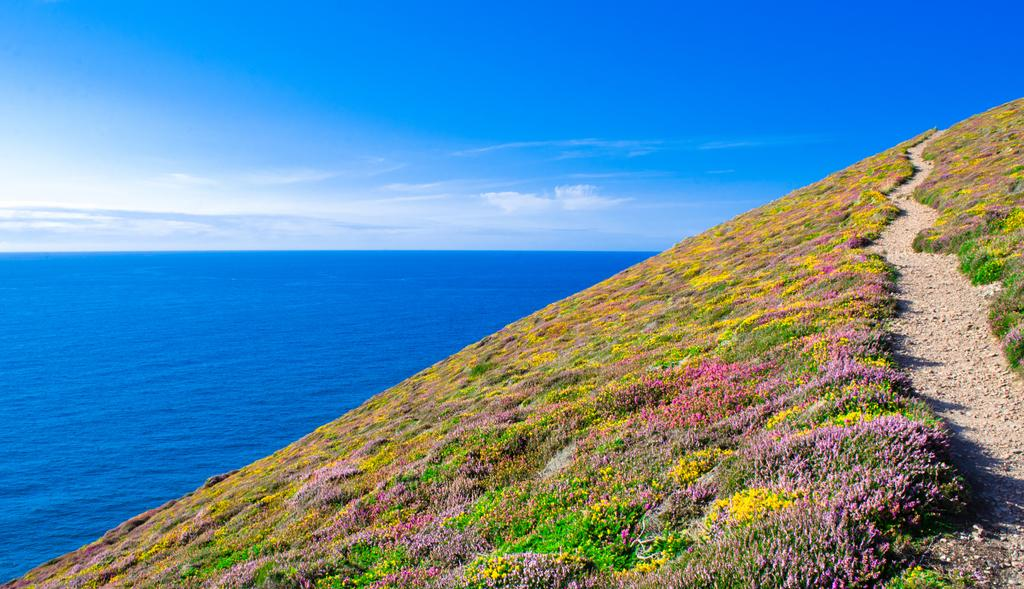What type of vegetation is present in the image? There is green grass in the image. Where are the small plants located in the image? The small plants are in the right corner of the image. What is in the left corner of the image? There is water in the left corner of the image. What can be seen above the grass and water in the image? The sky is visible at the top of the image. What is the weight of the company in the image? There is no company present in the image, so it is not possible to determine its weight. 